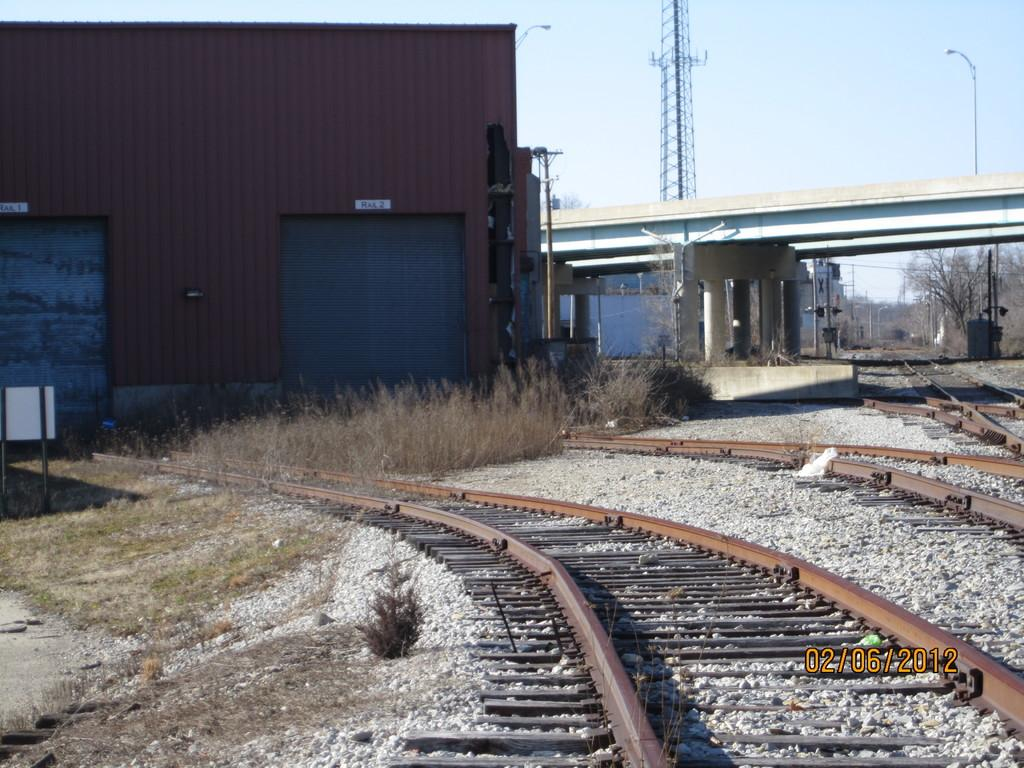What type of structure can be seen in the image? There is a shed in the image. What other man-made structures are visible in the image? There is a bridge, street poles, street lights, and a tower in the image. What natural elements can be seen in the image? Trees, grass, and stones are present in the image. What is the ground surface like in the image? The ground is visible in the image. Are there any transportation-related features in the image? Yes, railway tracks are visible in the image. How many eyes can be seen on the head of the person in the image? There is no person present in the image, so there are no eyes or heads visible. What type of meal is being prepared on the stove in the image? There is no stove or meal preparation visible in the image. 